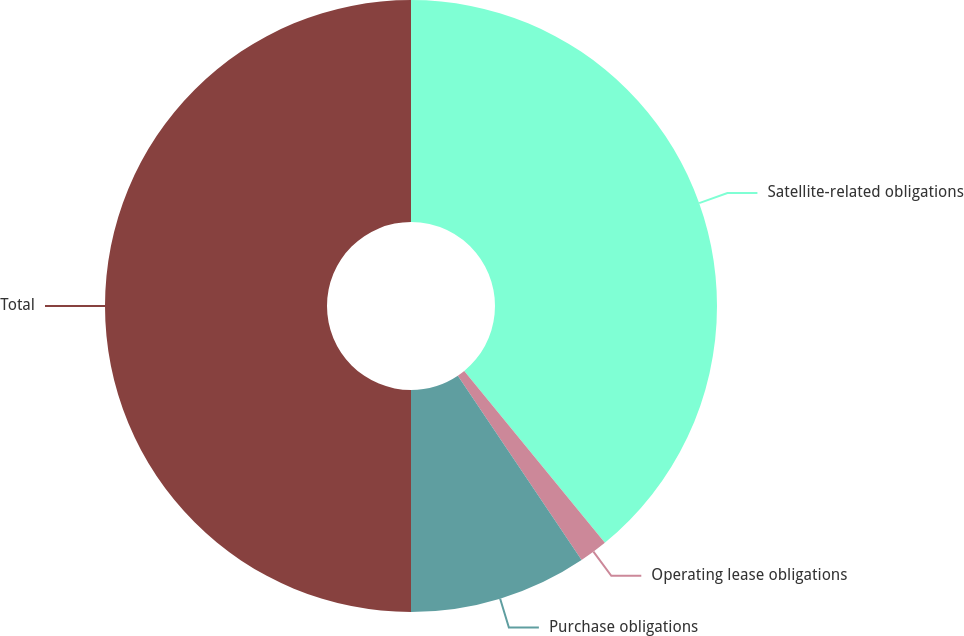Convert chart. <chart><loc_0><loc_0><loc_500><loc_500><pie_chart><fcel>Satellite-related obligations<fcel>Operating lease obligations<fcel>Purchase obligations<fcel>Total<nl><fcel>39.08%<fcel>1.51%<fcel>9.41%<fcel>50.0%<nl></chart> 